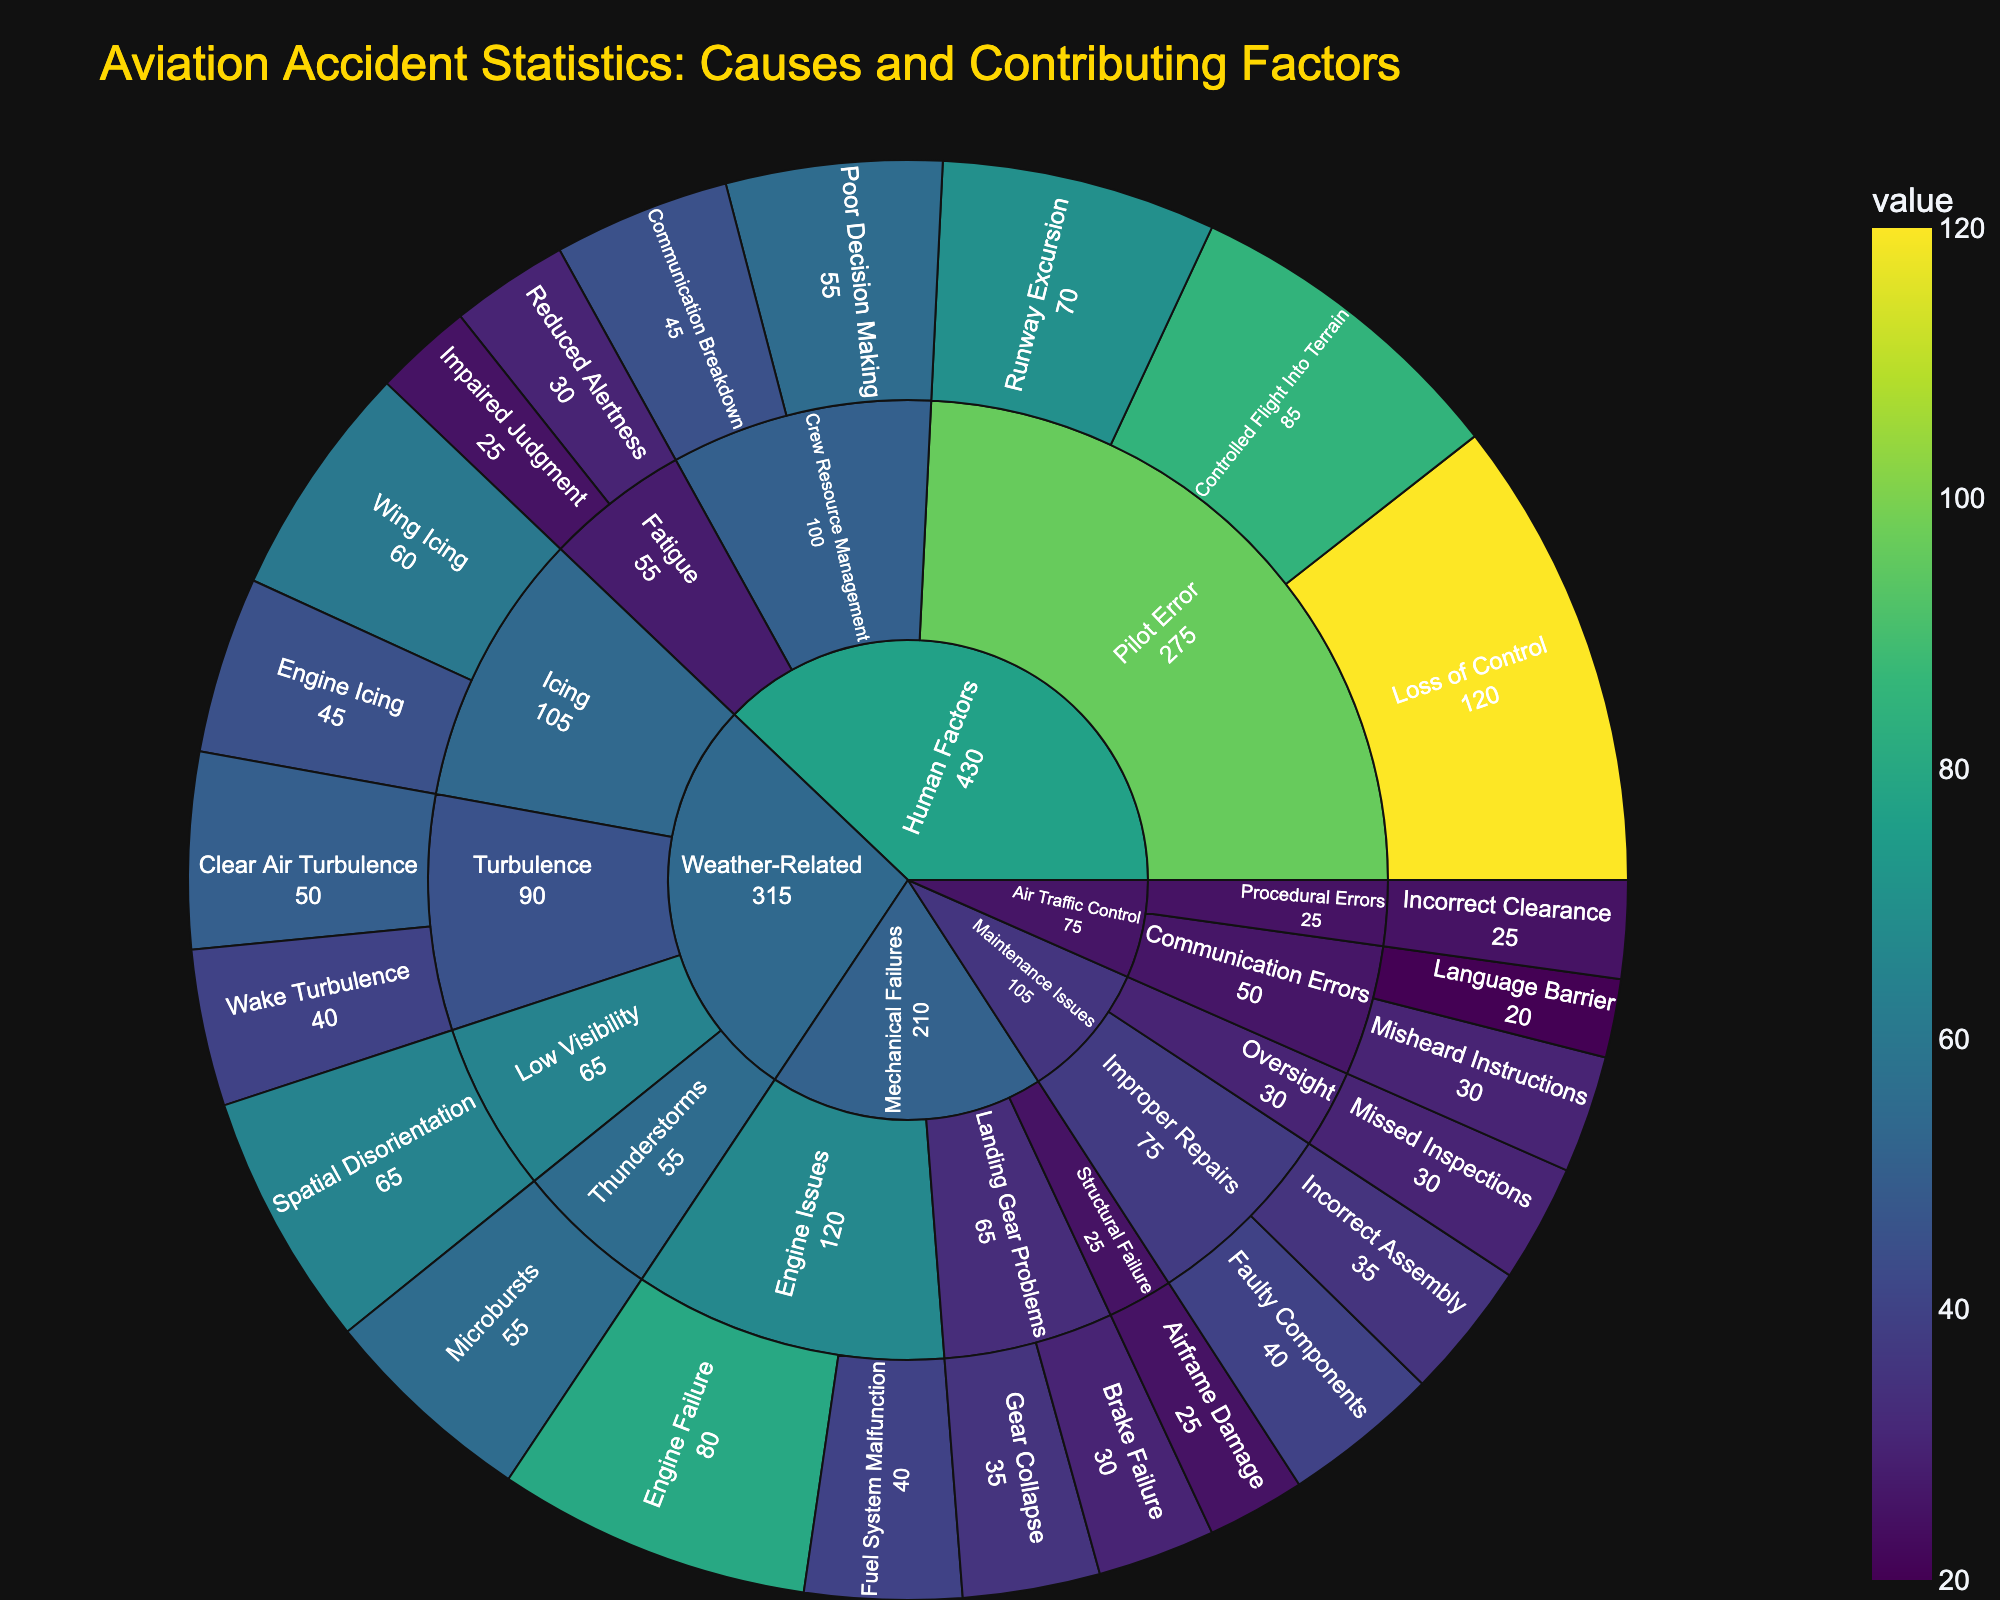What is the highest individual cause of aviation accidents? Look at the segment with the longest arc in the innermost ring; "Loss of Control" under "Human Factors" has the highest count with 120.
Answer: Loss of Control Which category has the most accidents due to Pilot Error? Observe the sectors under "Pilot Error" in the "Human Factors" category; "Loss of Control" has 120, "Controlled Flight Into Terrain" has 85, and "Runway Excursion" has 70. Summing these up gives us a total of 275.
Answer: Human Factors How many accidents are there due to mechanical failures related to engine issues? Identify the sectors under "Engine Issues" in the "Mechanical Failures" category and sum their values; "Engine Failure" has 80 and "Fuel System Malfunction" has 40, totaling 120.
Answer: 120 Which has more accidents: Brake Failure or Gear Collapse? Compare the values for "Brake Failure" and "Gear Collapse" in the "Landing Gear Problems" subcategory; "Gear Collapse" has 35 and "Brake Failure" has 30.
Answer: Gear Collapse Which subcategory under Weather-Related has the highest number of accidents? Look at the outer segments in the "Weather-Related" category; "Low Visibility" with "Spatial Disorientation" has the highest count of 65.
Answer: Low Visibility How many total accidents are attributed to Fatigue under Human Factors? Sum the values under "Fatigue" in the "Human Factors" category; "Reduced Alertness" has 30 and "Impaired Judgment" has 25, totaling 55.
Answer: 55 Which has more accidents: Incorrect Assembly or Misheard Instructions? Compare the values; "Incorrect Assembly" has 35 under "Improper Repairs," and "Misheard Instructions" has 30 under "Communication Errors."
Answer: Incorrect Assembly What is the total number of accidents due to Weather-Related causes? Sum the values of all segments under "Weather-Related"; Clear Air Turbulence (50), Wake Turbulence (40), Wing Icing (60), Engine Icing (45), Storms - Microbursts (55), and Spatial Disorientation (65), totaling 315.
Answer: 315 How many accidents are caused by Crew Resource Management in Human Factors? Sum the values under "Crew Resource Management" in "Human Factors"; "Communication Breakdown" has 45 and "Poor Decision Making" has 55, totaling 100.
Answer: 100 